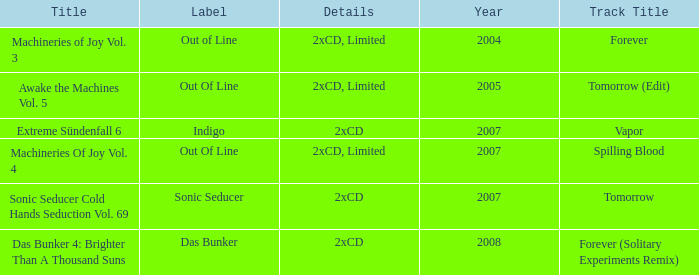Which details has the out of line label and the year of 2005? 2xCD, Limited. 